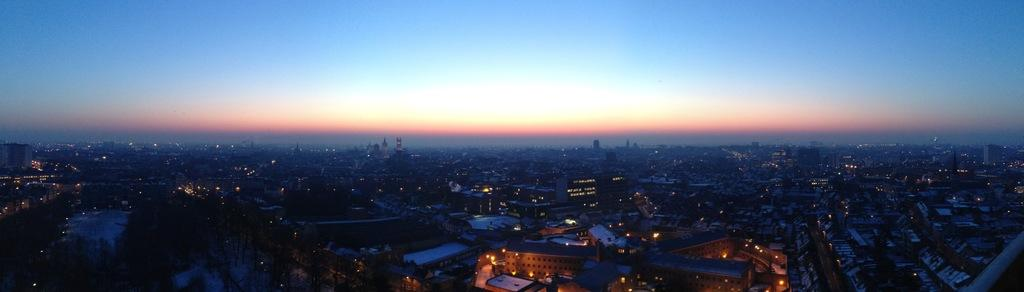What type of view is provided in the image? The image is an aerial view. What structures can be seen from this perspective? There are buildings in the image. What else is visible in the image besides the buildings? Lights are visible in the image. What can be seen in the background of the image? There is sky visible in the background of the image. What type of bells can be heard ringing in the image? There are no bells present in the image, and therefore no sound can be heard. What color is the crib in the image? There is no crib present in the image. 